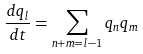Convert formula to latex. <formula><loc_0><loc_0><loc_500><loc_500>\frac { d q _ { l } } { d t } = \sum _ { n + m = l - 1 } q _ { n } q _ { m }</formula> 